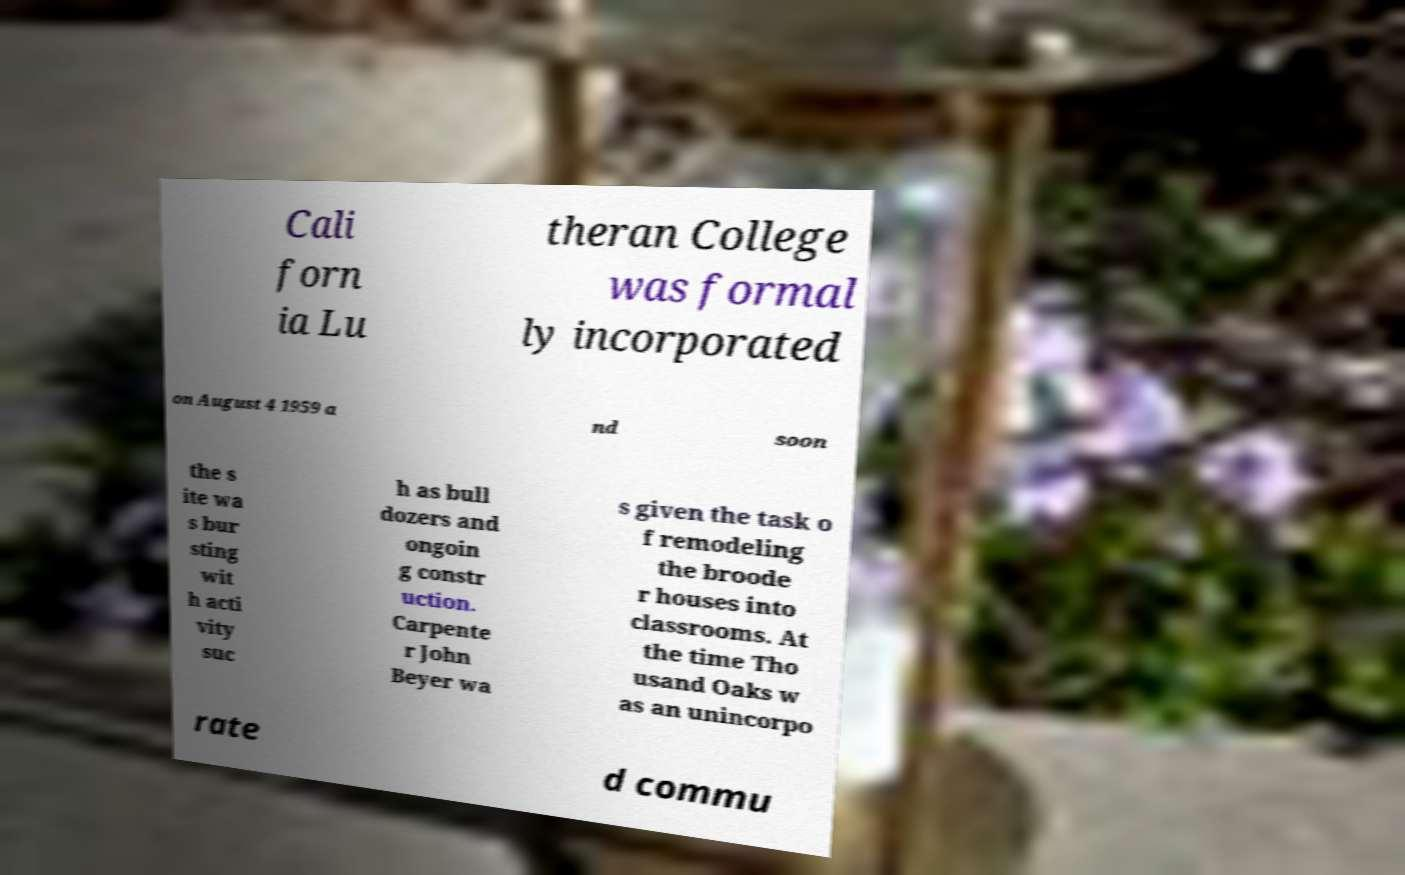Can you accurately transcribe the text from the provided image for me? Cali forn ia Lu theran College was formal ly incorporated on August 4 1959 a nd soon the s ite wa s bur sting wit h acti vity suc h as bull dozers and ongoin g constr uction. Carpente r John Beyer wa s given the task o f remodeling the broode r houses into classrooms. At the time Tho usand Oaks w as an unincorpo rate d commu 